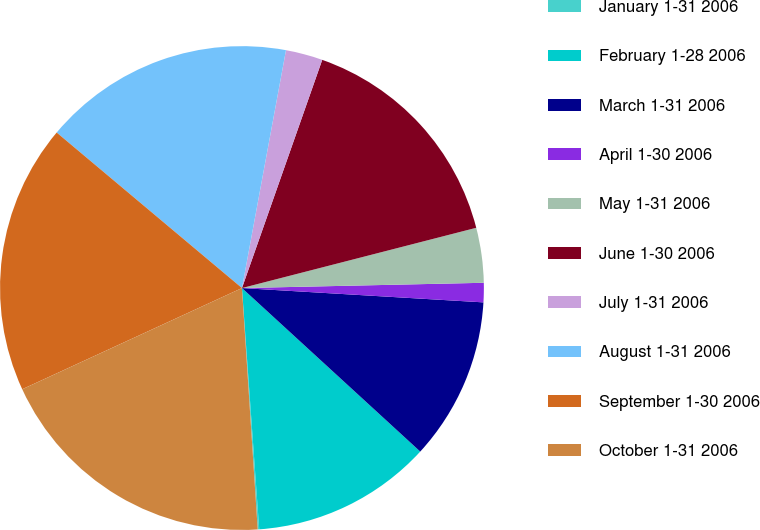Convert chart to OTSL. <chart><loc_0><loc_0><loc_500><loc_500><pie_chart><fcel>January 1-31 2006<fcel>February 1-28 2006<fcel>March 1-31 2006<fcel>April 1-30 2006<fcel>May 1-31 2006<fcel>June 1-30 2006<fcel>July 1-31 2006<fcel>August 1-31 2006<fcel>September 1-30 2006<fcel>October 1-31 2006<nl><fcel>0.1%<fcel>12.05%<fcel>10.87%<fcel>1.29%<fcel>3.66%<fcel>15.61%<fcel>2.47%<fcel>16.8%<fcel>17.98%<fcel>19.17%<nl></chart> 